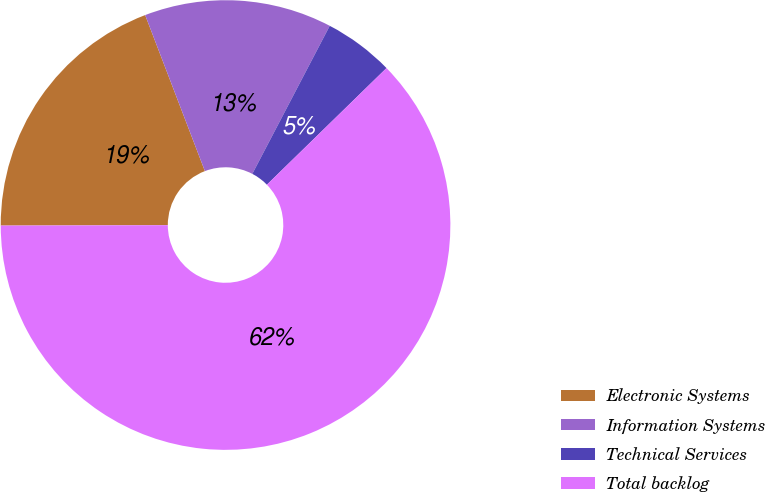<chart> <loc_0><loc_0><loc_500><loc_500><pie_chart><fcel>Electronic Systems<fcel>Information Systems<fcel>Technical Services<fcel>Total backlog<nl><fcel>19.22%<fcel>13.49%<fcel>5.03%<fcel>62.26%<nl></chart> 